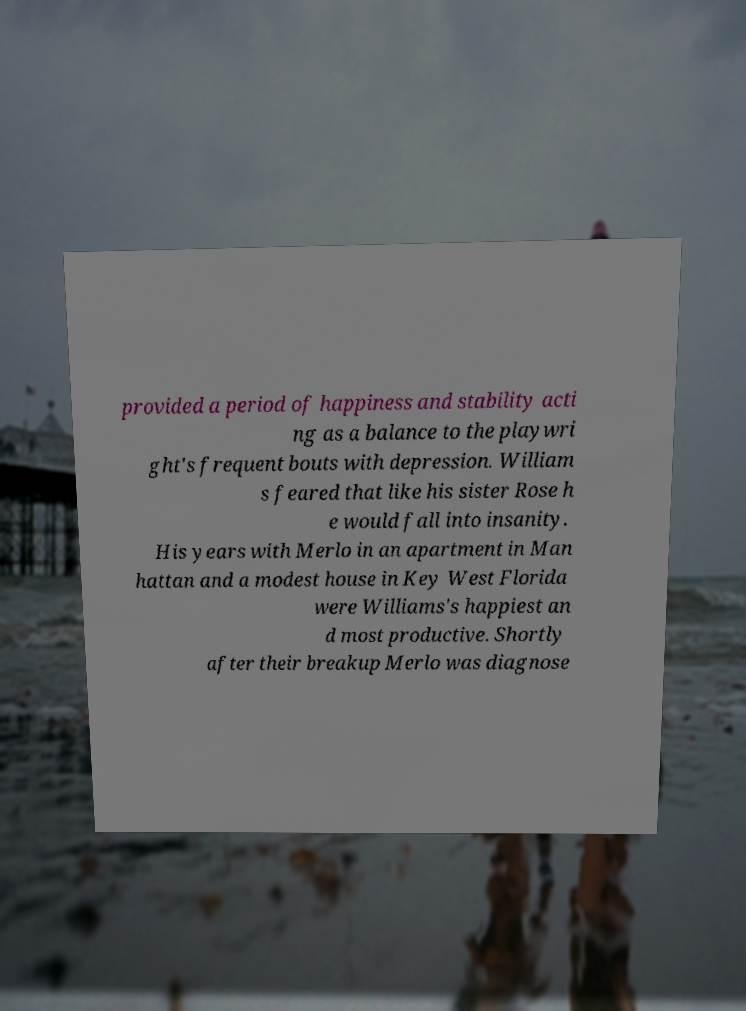Please read and relay the text visible in this image. What does it say? provided a period of happiness and stability acti ng as a balance to the playwri ght's frequent bouts with depression. William s feared that like his sister Rose h e would fall into insanity. His years with Merlo in an apartment in Man hattan and a modest house in Key West Florida were Williams's happiest an d most productive. Shortly after their breakup Merlo was diagnose 